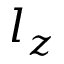<formula> <loc_0><loc_0><loc_500><loc_500>l _ { z }</formula> 